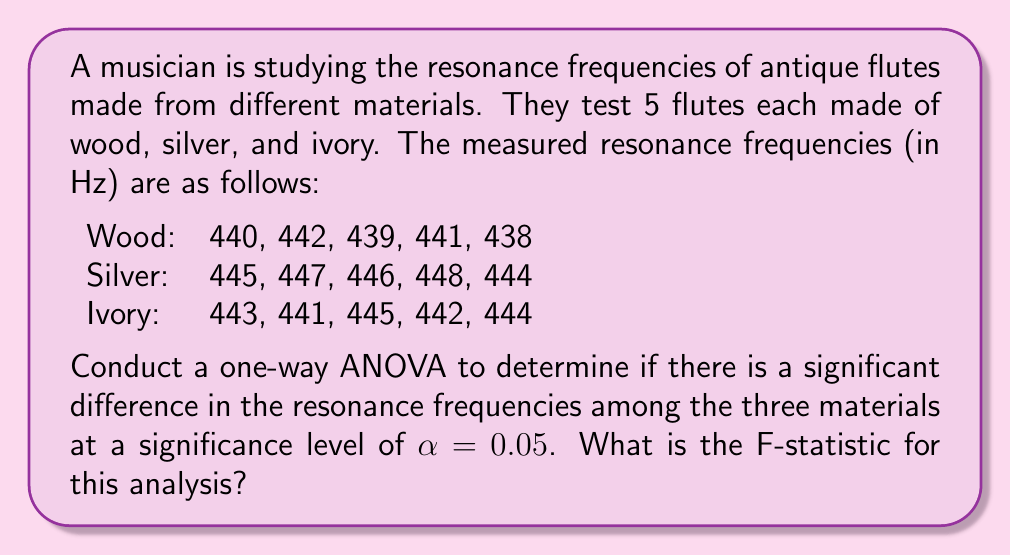Could you help me with this problem? To conduct a one-way ANOVA, we need to follow these steps:

1. Calculate the overall mean:
   $\bar{X} = \frac{440 + 442 + ... + 442 + 444}{15} = 443$ Hz

2. Calculate the sum of squares total (SST):
   $$SST = \sum_{i=1}^{15} (X_i - \bar{X})^2 = 166$$

3. Calculate the sum of squares between groups (SSB):
   $$SSB = 5[(440.0 - 443)^2 + (446.0 - 443)^2 + (443.0 - 443)^2] = 90$$

4. Calculate the sum of squares within groups (SSW):
   $$SSW = SST - SSB = 166 - 90 = 76$$

5. Calculate degrees of freedom:
   $df_{between} = k - 1 = 3 - 1 = 2$
   $df_{within} = N - k = 15 - 3 = 12$
   where $k$ is the number of groups and $N$ is the total number of observations.

6. Calculate mean squares:
   $$MS_{between} = \frac{SSB}{df_{between}} = \frac{90}{2} = 45$$
   $$MS_{within} = \frac{SSW}{df_{within}} = \frac{76}{12} = 6.33$$

7. Calculate the F-statistic:
   $$F = \frac{MS_{between}}{MS_{within}} = \frac{45}{6.33} = 7.11$$

The F-statistic for this analysis is 7.11.
Answer: 7.11 